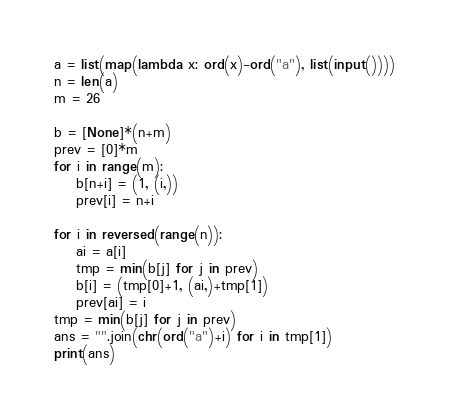Convert code to text. <code><loc_0><loc_0><loc_500><loc_500><_Python_>a = list(map(lambda x: ord(x)-ord("a"), list(input())))
n = len(a)
m = 26

b = [None]*(n+m)
prev = [0]*m
for i in range(m):
    b[n+i] = (1, (i,))
    prev[i] = n+i

for i in reversed(range(n)):
    ai = a[i]
    tmp = min(b[j] for j in prev)
    b[i] = (tmp[0]+1, (ai,)+tmp[1])
    prev[ai] = i
tmp = min(b[j] for j in prev)
ans = "".join(chr(ord("a")+i) for i in tmp[1])
print(ans)</code> 